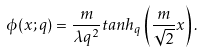<formula> <loc_0><loc_0><loc_500><loc_500>\phi ( x ; q ) = \frac { m } { \lambda q ^ { 2 } } t a n h _ { q } \left ( \frac { m } { \sqrt { 2 } } x \right ) .</formula> 